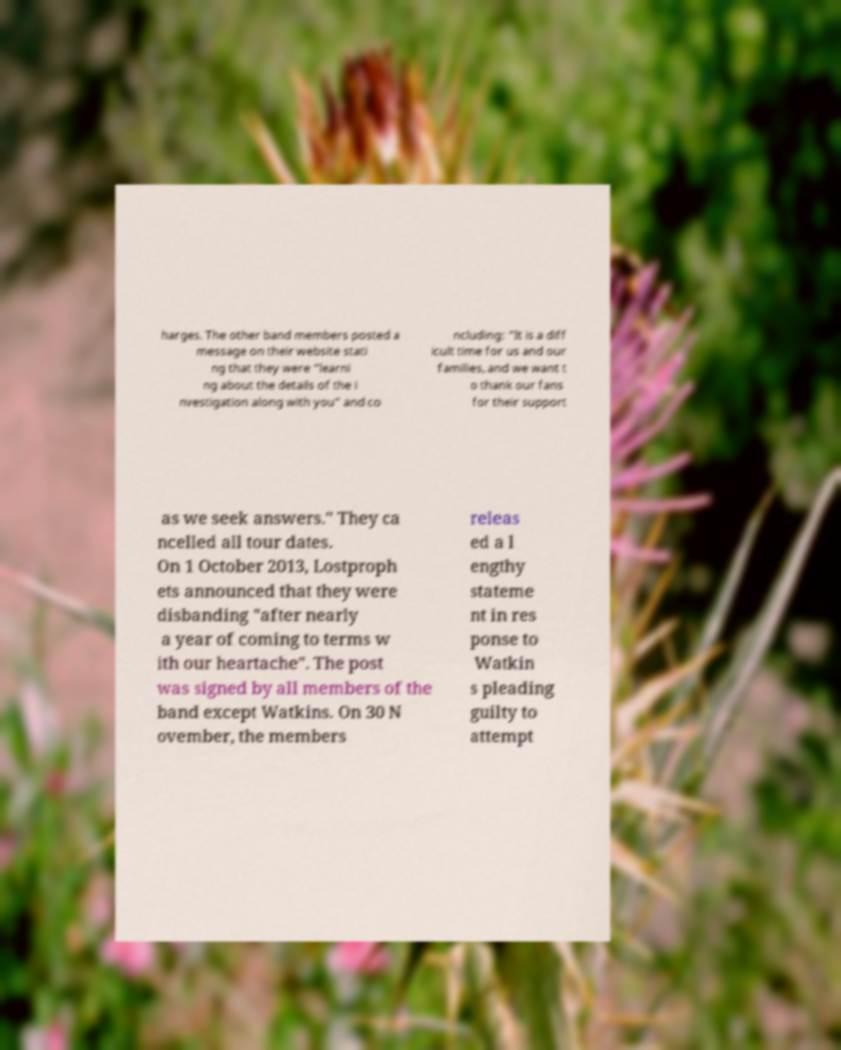Please read and relay the text visible in this image. What does it say? harges. The other band members posted a message on their website stati ng that they were "learni ng about the details of the i nvestigation along with you" and co ncluding: "It is a diff icult time for us and our families, and we want t o thank our fans for their support as we seek answers." They ca ncelled all tour dates. On 1 October 2013, Lostproph ets announced that they were disbanding "after nearly a year of coming to terms w ith our heartache". The post was signed by all members of the band except Watkins. On 30 N ovember, the members releas ed a l engthy stateme nt in res ponse to Watkin s pleading guilty to attempt 